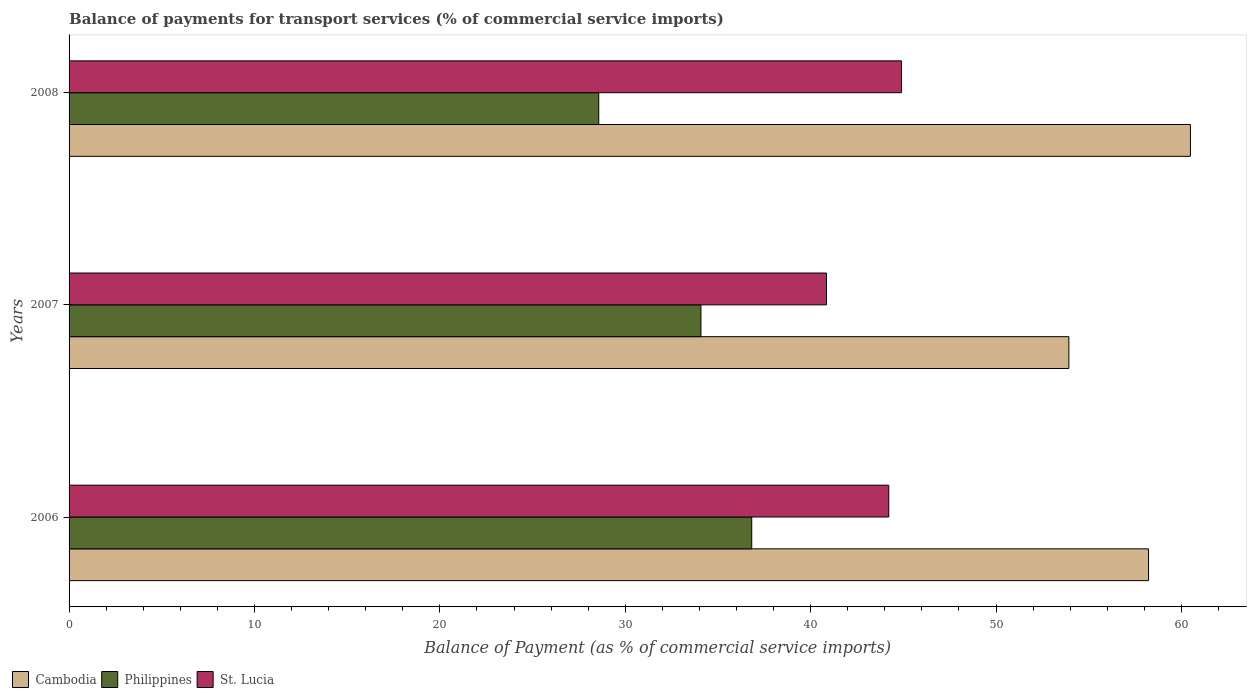How many different coloured bars are there?
Ensure brevity in your answer.  3. Are the number of bars on each tick of the Y-axis equal?
Your answer should be very brief. Yes. In how many cases, is the number of bars for a given year not equal to the number of legend labels?
Your answer should be very brief. 0. What is the balance of payments for transport services in Philippines in 2008?
Keep it short and to the point. 28.57. Across all years, what is the maximum balance of payments for transport services in Philippines?
Ensure brevity in your answer.  36.82. Across all years, what is the minimum balance of payments for transport services in Philippines?
Ensure brevity in your answer.  28.57. In which year was the balance of payments for transport services in Cambodia maximum?
Ensure brevity in your answer.  2008. What is the total balance of payments for transport services in Cambodia in the graph?
Your answer should be compact. 172.63. What is the difference between the balance of payments for transport services in St. Lucia in 2007 and that in 2008?
Offer a terse response. -4.04. What is the difference between the balance of payments for transport services in Cambodia in 2006 and the balance of payments for transport services in St. Lucia in 2008?
Your answer should be compact. 13.33. What is the average balance of payments for transport services in Cambodia per year?
Your answer should be compact. 57.54. In the year 2007, what is the difference between the balance of payments for transport services in Cambodia and balance of payments for transport services in Philippines?
Offer a very short reply. 19.85. What is the ratio of the balance of payments for transport services in Cambodia in 2006 to that in 2008?
Ensure brevity in your answer.  0.96. Is the balance of payments for transport services in St. Lucia in 2006 less than that in 2007?
Give a very brief answer. No. Is the difference between the balance of payments for transport services in Cambodia in 2006 and 2007 greater than the difference between the balance of payments for transport services in Philippines in 2006 and 2007?
Your response must be concise. Yes. What is the difference between the highest and the second highest balance of payments for transport services in Cambodia?
Your answer should be compact. 2.26. What is the difference between the highest and the lowest balance of payments for transport services in Cambodia?
Make the answer very short. 6.56. In how many years, is the balance of payments for transport services in St. Lucia greater than the average balance of payments for transport services in St. Lucia taken over all years?
Keep it short and to the point. 2. Is the sum of the balance of payments for transport services in Philippines in 2006 and 2007 greater than the maximum balance of payments for transport services in Cambodia across all years?
Your response must be concise. Yes. What does the 2nd bar from the top in 2007 represents?
Ensure brevity in your answer.  Philippines. What does the 1st bar from the bottom in 2007 represents?
Offer a very short reply. Cambodia. How many bars are there?
Your answer should be very brief. 9. Are all the bars in the graph horizontal?
Ensure brevity in your answer.  Yes. How many years are there in the graph?
Provide a short and direct response. 3. Does the graph contain any zero values?
Your answer should be compact. No. Where does the legend appear in the graph?
Offer a very short reply. Bottom left. How are the legend labels stacked?
Your answer should be very brief. Horizontal. What is the title of the graph?
Offer a terse response. Balance of payments for transport services (% of commercial service imports). Does "Vietnam" appear as one of the legend labels in the graph?
Offer a terse response. No. What is the label or title of the X-axis?
Your response must be concise. Balance of Payment (as % of commercial service imports). What is the label or title of the Y-axis?
Provide a short and direct response. Years. What is the Balance of Payment (as % of commercial service imports) in Cambodia in 2006?
Provide a succinct answer. 58.22. What is the Balance of Payment (as % of commercial service imports) in Philippines in 2006?
Your answer should be very brief. 36.82. What is the Balance of Payment (as % of commercial service imports) of St. Lucia in 2006?
Ensure brevity in your answer.  44.21. What is the Balance of Payment (as % of commercial service imports) of Cambodia in 2007?
Keep it short and to the point. 53.93. What is the Balance of Payment (as % of commercial service imports) of Philippines in 2007?
Keep it short and to the point. 34.08. What is the Balance of Payment (as % of commercial service imports) of St. Lucia in 2007?
Keep it short and to the point. 40.85. What is the Balance of Payment (as % of commercial service imports) in Cambodia in 2008?
Your response must be concise. 60.48. What is the Balance of Payment (as % of commercial service imports) in Philippines in 2008?
Make the answer very short. 28.57. What is the Balance of Payment (as % of commercial service imports) of St. Lucia in 2008?
Provide a short and direct response. 44.9. Across all years, what is the maximum Balance of Payment (as % of commercial service imports) of Cambodia?
Give a very brief answer. 60.48. Across all years, what is the maximum Balance of Payment (as % of commercial service imports) of Philippines?
Give a very brief answer. 36.82. Across all years, what is the maximum Balance of Payment (as % of commercial service imports) in St. Lucia?
Keep it short and to the point. 44.9. Across all years, what is the minimum Balance of Payment (as % of commercial service imports) of Cambodia?
Make the answer very short. 53.93. Across all years, what is the minimum Balance of Payment (as % of commercial service imports) in Philippines?
Offer a terse response. 28.57. Across all years, what is the minimum Balance of Payment (as % of commercial service imports) of St. Lucia?
Provide a succinct answer. 40.85. What is the total Balance of Payment (as % of commercial service imports) in Cambodia in the graph?
Keep it short and to the point. 172.63. What is the total Balance of Payment (as % of commercial service imports) in Philippines in the graph?
Your response must be concise. 99.47. What is the total Balance of Payment (as % of commercial service imports) of St. Lucia in the graph?
Keep it short and to the point. 129.96. What is the difference between the Balance of Payment (as % of commercial service imports) of Cambodia in 2006 and that in 2007?
Your answer should be compact. 4.3. What is the difference between the Balance of Payment (as % of commercial service imports) of Philippines in 2006 and that in 2007?
Your answer should be very brief. 2.74. What is the difference between the Balance of Payment (as % of commercial service imports) in St. Lucia in 2006 and that in 2007?
Your response must be concise. 3.36. What is the difference between the Balance of Payment (as % of commercial service imports) of Cambodia in 2006 and that in 2008?
Provide a succinct answer. -2.26. What is the difference between the Balance of Payment (as % of commercial service imports) in Philippines in 2006 and that in 2008?
Make the answer very short. 8.25. What is the difference between the Balance of Payment (as % of commercial service imports) of St. Lucia in 2006 and that in 2008?
Your answer should be very brief. -0.69. What is the difference between the Balance of Payment (as % of commercial service imports) of Cambodia in 2007 and that in 2008?
Offer a terse response. -6.56. What is the difference between the Balance of Payment (as % of commercial service imports) of Philippines in 2007 and that in 2008?
Your response must be concise. 5.51. What is the difference between the Balance of Payment (as % of commercial service imports) of St. Lucia in 2007 and that in 2008?
Provide a succinct answer. -4.04. What is the difference between the Balance of Payment (as % of commercial service imports) in Cambodia in 2006 and the Balance of Payment (as % of commercial service imports) in Philippines in 2007?
Ensure brevity in your answer.  24.14. What is the difference between the Balance of Payment (as % of commercial service imports) in Cambodia in 2006 and the Balance of Payment (as % of commercial service imports) in St. Lucia in 2007?
Offer a very short reply. 17.37. What is the difference between the Balance of Payment (as % of commercial service imports) in Philippines in 2006 and the Balance of Payment (as % of commercial service imports) in St. Lucia in 2007?
Your response must be concise. -4.03. What is the difference between the Balance of Payment (as % of commercial service imports) in Cambodia in 2006 and the Balance of Payment (as % of commercial service imports) in Philippines in 2008?
Your response must be concise. 29.65. What is the difference between the Balance of Payment (as % of commercial service imports) of Cambodia in 2006 and the Balance of Payment (as % of commercial service imports) of St. Lucia in 2008?
Provide a short and direct response. 13.33. What is the difference between the Balance of Payment (as % of commercial service imports) in Philippines in 2006 and the Balance of Payment (as % of commercial service imports) in St. Lucia in 2008?
Your response must be concise. -8.08. What is the difference between the Balance of Payment (as % of commercial service imports) of Cambodia in 2007 and the Balance of Payment (as % of commercial service imports) of Philippines in 2008?
Provide a short and direct response. 25.36. What is the difference between the Balance of Payment (as % of commercial service imports) of Cambodia in 2007 and the Balance of Payment (as % of commercial service imports) of St. Lucia in 2008?
Offer a terse response. 9.03. What is the difference between the Balance of Payment (as % of commercial service imports) in Philippines in 2007 and the Balance of Payment (as % of commercial service imports) in St. Lucia in 2008?
Make the answer very short. -10.82. What is the average Balance of Payment (as % of commercial service imports) of Cambodia per year?
Ensure brevity in your answer.  57.54. What is the average Balance of Payment (as % of commercial service imports) of Philippines per year?
Your answer should be very brief. 33.16. What is the average Balance of Payment (as % of commercial service imports) in St. Lucia per year?
Give a very brief answer. 43.32. In the year 2006, what is the difference between the Balance of Payment (as % of commercial service imports) in Cambodia and Balance of Payment (as % of commercial service imports) in Philippines?
Provide a short and direct response. 21.4. In the year 2006, what is the difference between the Balance of Payment (as % of commercial service imports) of Cambodia and Balance of Payment (as % of commercial service imports) of St. Lucia?
Your response must be concise. 14.01. In the year 2006, what is the difference between the Balance of Payment (as % of commercial service imports) in Philippines and Balance of Payment (as % of commercial service imports) in St. Lucia?
Keep it short and to the point. -7.39. In the year 2007, what is the difference between the Balance of Payment (as % of commercial service imports) of Cambodia and Balance of Payment (as % of commercial service imports) of Philippines?
Ensure brevity in your answer.  19.85. In the year 2007, what is the difference between the Balance of Payment (as % of commercial service imports) in Cambodia and Balance of Payment (as % of commercial service imports) in St. Lucia?
Give a very brief answer. 13.07. In the year 2007, what is the difference between the Balance of Payment (as % of commercial service imports) in Philippines and Balance of Payment (as % of commercial service imports) in St. Lucia?
Offer a very short reply. -6.77. In the year 2008, what is the difference between the Balance of Payment (as % of commercial service imports) in Cambodia and Balance of Payment (as % of commercial service imports) in Philippines?
Your answer should be compact. 31.91. In the year 2008, what is the difference between the Balance of Payment (as % of commercial service imports) of Cambodia and Balance of Payment (as % of commercial service imports) of St. Lucia?
Your response must be concise. 15.59. In the year 2008, what is the difference between the Balance of Payment (as % of commercial service imports) of Philippines and Balance of Payment (as % of commercial service imports) of St. Lucia?
Your answer should be very brief. -16.33. What is the ratio of the Balance of Payment (as % of commercial service imports) of Cambodia in 2006 to that in 2007?
Offer a terse response. 1.08. What is the ratio of the Balance of Payment (as % of commercial service imports) in Philippines in 2006 to that in 2007?
Provide a short and direct response. 1.08. What is the ratio of the Balance of Payment (as % of commercial service imports) of St. Lucia in 2006 to that in 2007?
Keep it short and to the point. 1.08. What is the ratio of the Balance of Payment (as % of commercial service imports) in Cambodia in 2006 to that in 2008?
Your answer should be compact. 0.96. What is the ratio of the Balance of Payment (as % of commercial service imports) in Philippines in 2006 to that in 2008?
Give a very brief answer. 1.29. What is the ratio of the Balance of Payment (as % of commercial service imports) of St. Lucia in 2006 to that in 2008?
Offer a terse response. 0.98. What is the ratio of the Balance of Payment (as % of commercial service imports) of Cambodia in 2007 to that in 2008?
Provide a short and direct response. 0.89. What is the ratio of the Balance of Payment (as % of commercial service imports) in Philippines in 2007 to that in 2008?
Your answer should be compact. 1.19. What is the ratio of the Balance of Payment (as % of commercial service imports) in St. Lucia in 2007 to that in 2008?
Your answer should be very brief. 0.91. What is the difference between the highest and the second highest Balance of Payment (as % of commercial service imports) of Cambodia?
Keep it short and to the point. 2.26. What is the difference between the highest and the second highest Balance of Payment (as % of commercial service imports) of Philippines?
Keep it short and to the point. 2.74. What is the difference between the highest and the second highest Balance of Payment (as % of commercial service imports) of St. Lucia?
Provide a short and direct response. 0.69. What is the difference between the highest and the lowest Balance of Payment (as % of commercial service imports) of Cambodia?
Keep it short and to the point. 6.56. What is the difference between the highest and the lowest Balance of Payment (as % of commercial service imports) in Philippines?
Offer a terse response. 8.25. What is the difference between the highest and the lowest Balance of Payment (as % of commercial service imports) of St. Lucia?
Provide a succinct answer. 4.04. 